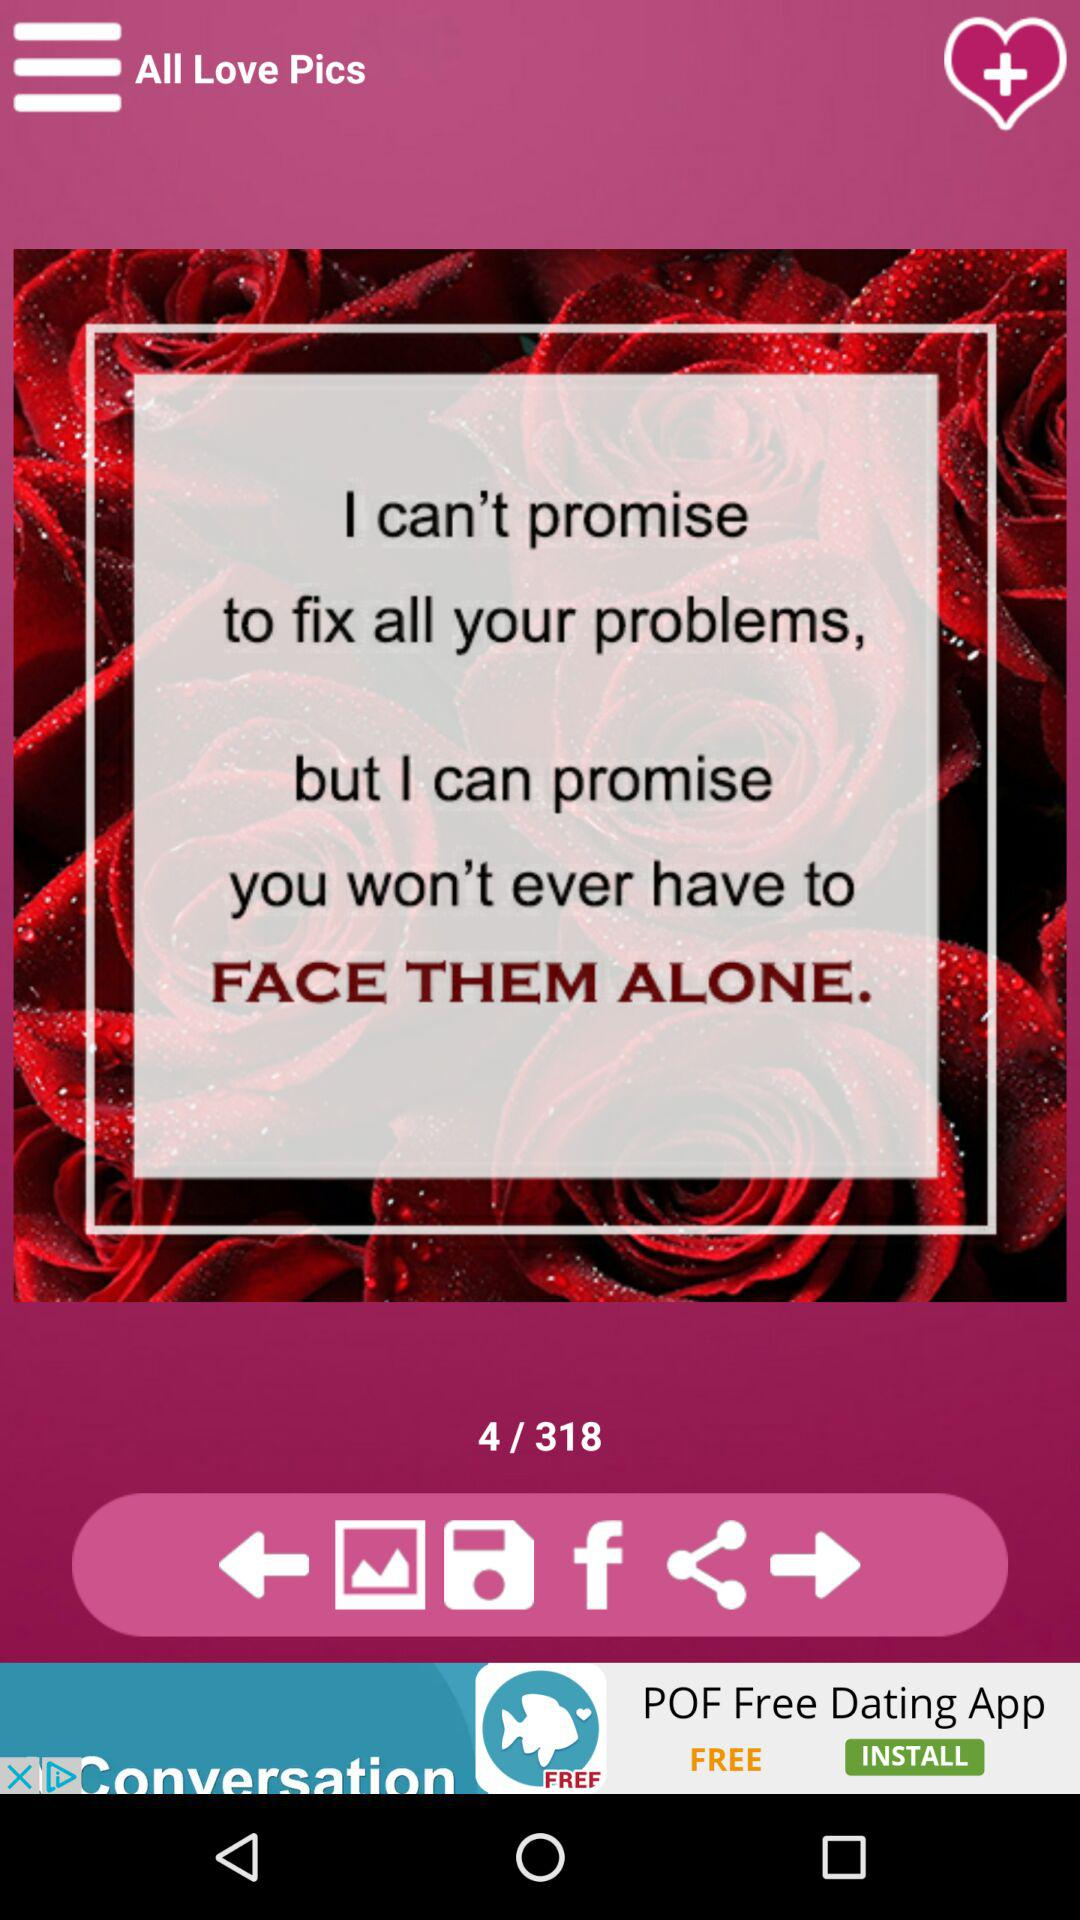Which slide is currently open on the screen? Currently, slide 4 is open on the screen. 